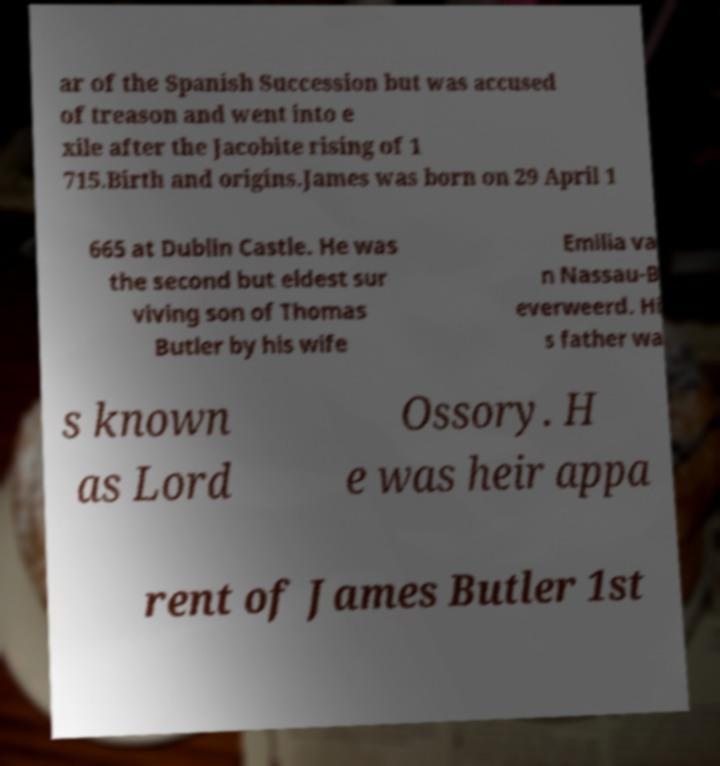Can you read and provide the text displayed in the image?This photo seems to have some interesting text. Can you extract and type it out for me? ar of the Spanish Succession but was accused of treason and went into e xile after the Jacobite rising of 1 715.Birth and origins.James was born on 29 April 1 665 at Dublin Castle. He was the second but eldest sur viving son of Thomas Butler by his wife Emilia va n Nassau-B everweerd. Hi s father wa s known as Lord Ossory. H e was heir appa rent of James Butler 1st 